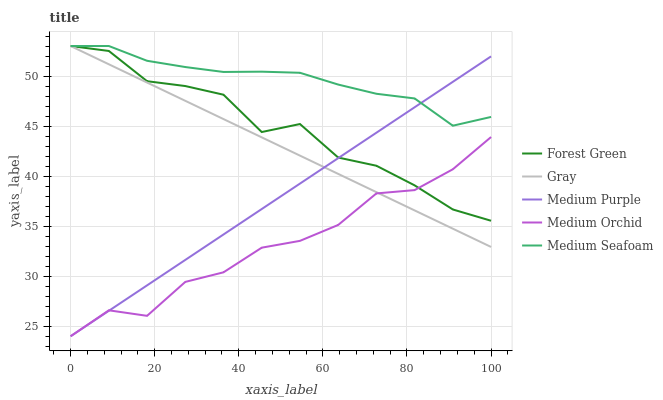Does Medium Orchid have the minimum area under the curve?
Answer yes or no. Yes. Does Medium Seafoam have the maximum area under the curve?
Answer yes or no. Yes. Does Gray have the minimum area under the curve?
Answer yes or no. No. Does Gray have the maximum area under the curve?
Answer yes or no. No. Is Medium Purple the smoothest?
Answer yes or no. Yes. Is Forest Green the roughest?
Answer yes or no. Yes. Is Gray the smoothest?
Answer yes or no. No. Is Gray the roughest?
Answer yes or no. No. Does Medium Purple have the lowest value?
Answer yes or no. Yes. Does Gray have the lowest value?
Answer yes or no. No. Does Medium Seafoam have the highest value?
Answer yes or no. Yes. Does Medium Orchid have the highest value?
Answer yes or no. No. Is Medium Orchid less than Medium Seafoam?
Answer yes or no. Yes. Is Medium Seafoam greater than Medium Orchid?
Answer yes or no. Yes. Does Forest Green intersect Medium Seafoam?
Answer yes or no. Yes. Is Forest Green less than Medium Seafoam?
Answer yes or no. No. Is Forest Green greater than Medium Seafoam?
Answer yes or no. No. Does Medium Orchid intersect Medium Seafoam?
Answer yes or no. No. 